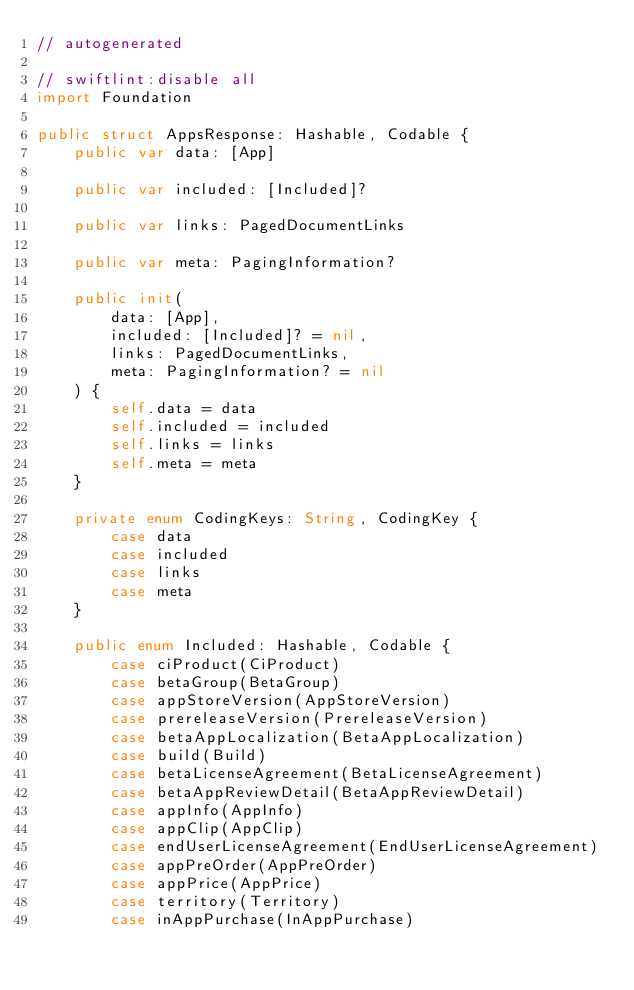Convert code to text. <code><loc_0><loc_0><loc_500><loc_500><_Swift_>// autogenerated

// swiftlint:disable all
import Foundation

public struct AppsResponse: Hashable, Codable {
    public var data: [App]

    public var included: [Included]?

    public var links: PagedDocumentLinks

    public var meta: PagingInformation?

    public init(
        data: [App],
        included: [Included]? = nil,
        links: PagedDocumentLinks,
        meta: PagingInformation? = nil
    ) {
        self.data = data
        self.included = included
        self.links = links
        self.meta = meta
    }

    private enum CodingKeys: String, CodingKey {
        case data
        case included
        case links
        case meta
    }

    public enum Included: Hashable, Codable {
        case ciProduct(CiProduct)
        case betaGroup(BetaGroup)
        case appStoreVersion(AppStoreVersion)
        case prereleaseVersion(PrereleaseVersion)
        case betaAppLocalization(BetaAppLocalization)
        case build(Build)
        case betaLicenseAgreement(BetaLicenseAgreement)
        case betaAppReviewDetail(BetaAppReviewDetail)
        case appInfo(AppInfo)
        case appClip(AppClip)
        case endUserLicenseAgreement(EndUserLicenseAgreement)
        case appPreOrder(AppPreOrder)
        case appPrice(AppPrice)
        case territory(Territory)
        case inAppPurchase(InAppPurchase)</code> 